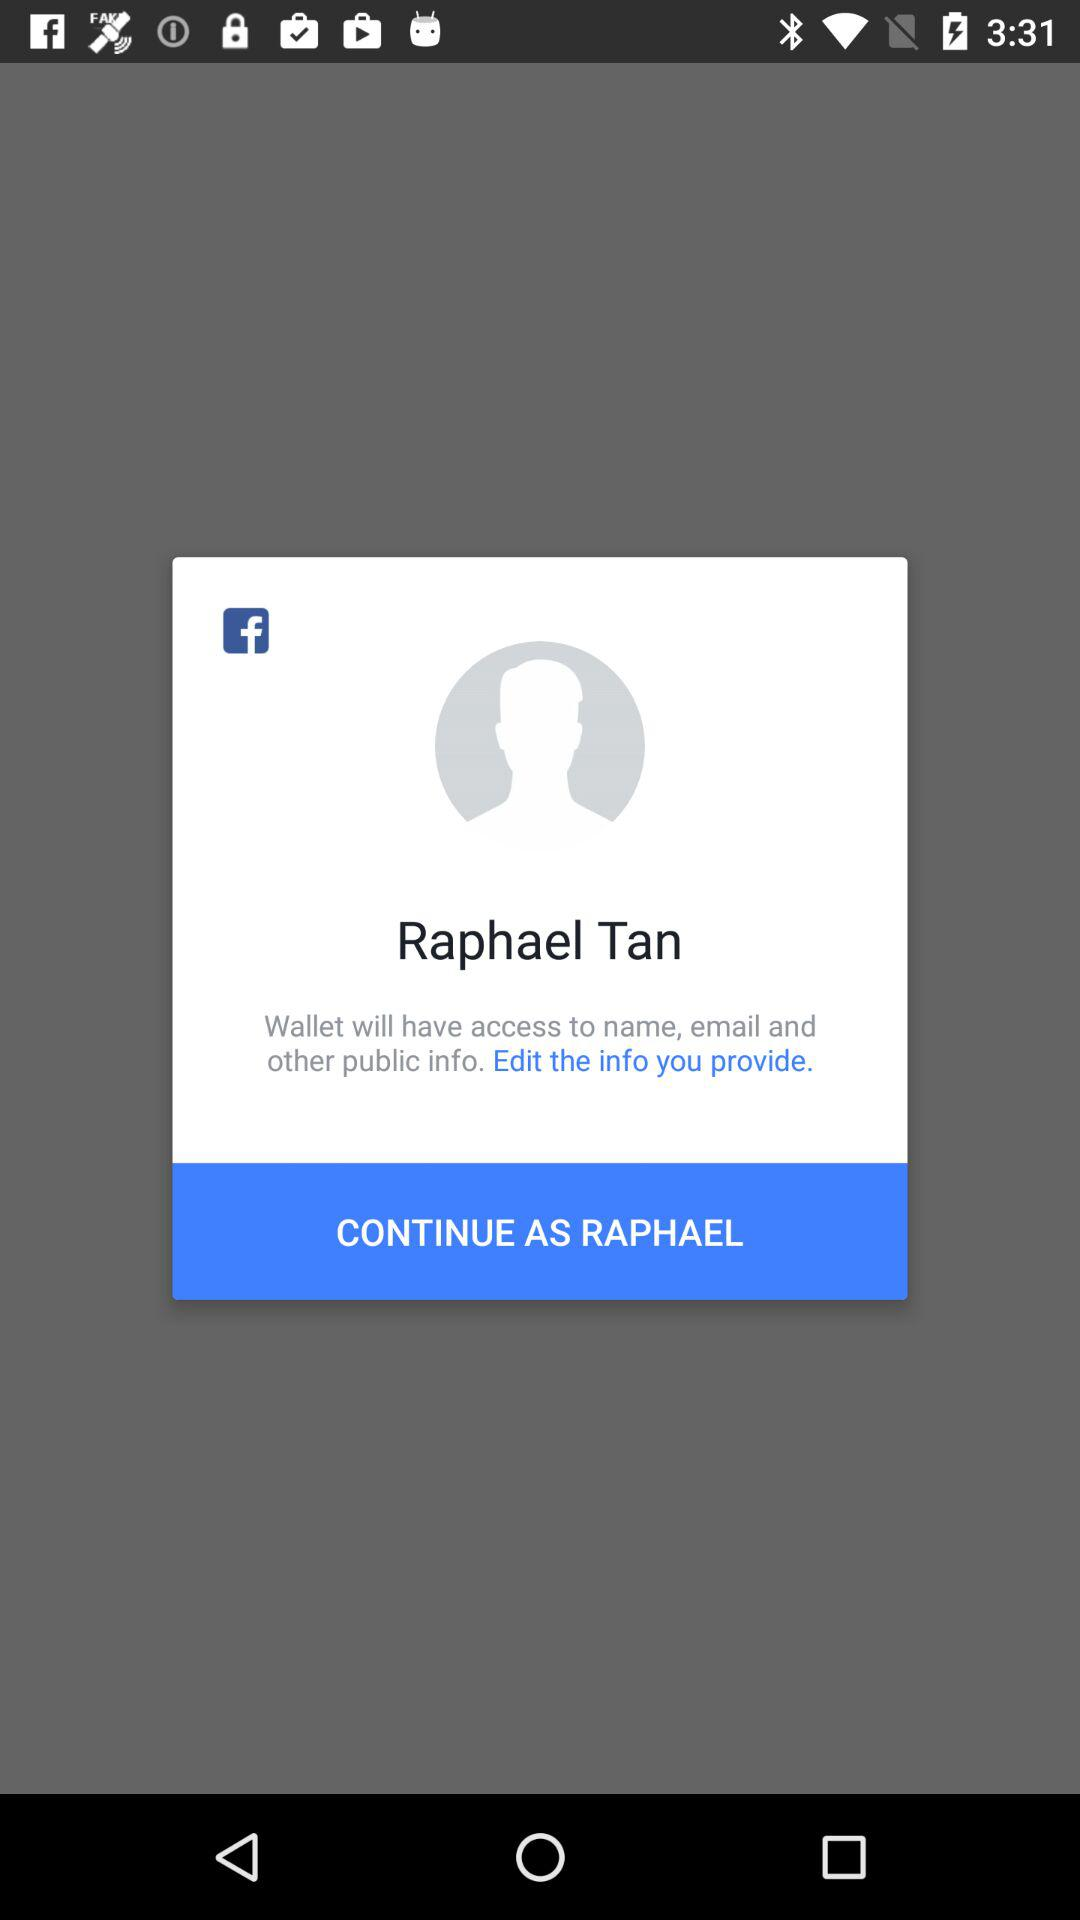What's the user profile name? The user profile name is Raphael Tan. 